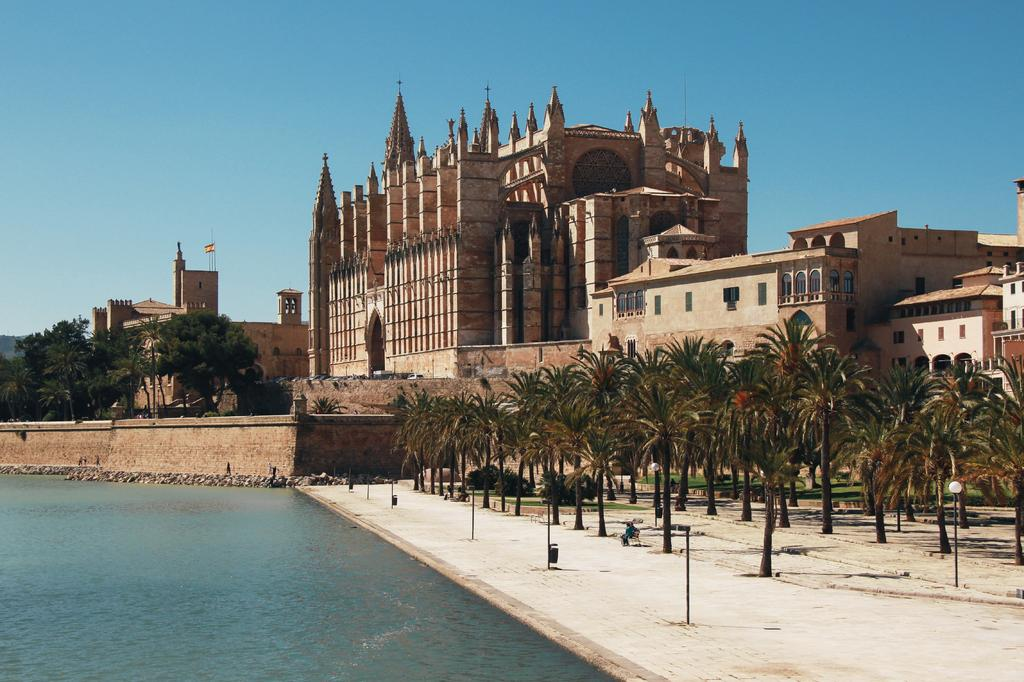What type of natural elements can be seen in the image? There are trees and water visible in the image. What type of structures are present in the image? There are buildings with windows in the image. What symbol can be seen in the image? There is a flag in the image. What is visible in the background of the image? The sky is visible in the background of the image. What type of disease is affecting the trees in the image? There is no indication of any disease affecting the trees in the image; they appear healthy. Can you describe the mouth of the building in the image? There is no mouth present in the image, as buildings do not have mouths. 